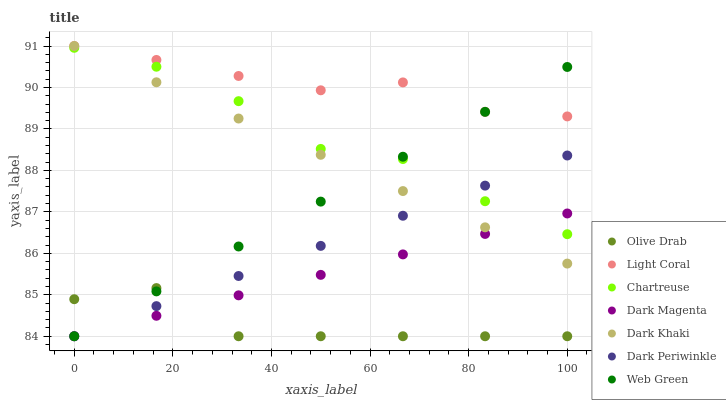Does Olive Drab have the minimum area under the curve?
Answer yes or no. Yes. Does Light Coral have the maximum area under the curve?
Answer yes or no. Yes. Does Dark Magenta have the minimum area under the curve?
Answer yes or no. No. Does Dark Magenta have the maximum area under the curve?
Answer yes or no. No. Is Dark Periwinkle the smoothest?
Answer yes or no. Yes. Is Chartreuse the roughest?
Answer yes or no. Yes. Is Dark Magenta the smoothest?
Answer yes or no. No. Is Dark Magenta the roughest?
Answer yes or no. No. Does Dark Magenta have the lowest value?
Answer yes or no. Yes. Does Light Coral have the lowest value?
Answer yes or no. No. Does Light Coral have the highest value?
Answer yes or no. Yes. Does Dark Magenta have the highest value?
Answer yes or no. No. Is Chartreuse less than Light Coral?
Answer yes or no. Yes. Is Chartreuse greater than Olive Drab?
Answer yes or no. Yes. Does Olive Drab intersect Web Green?
Answer yes or no. Yes. Is Olive Drab less than Web Green?
Answer yes or no. No. Is Olive Drab greater than Web Green?
Answer yes or no. No. Does Chartreuse intersect Light Coral?
Answer yes or no. No. 